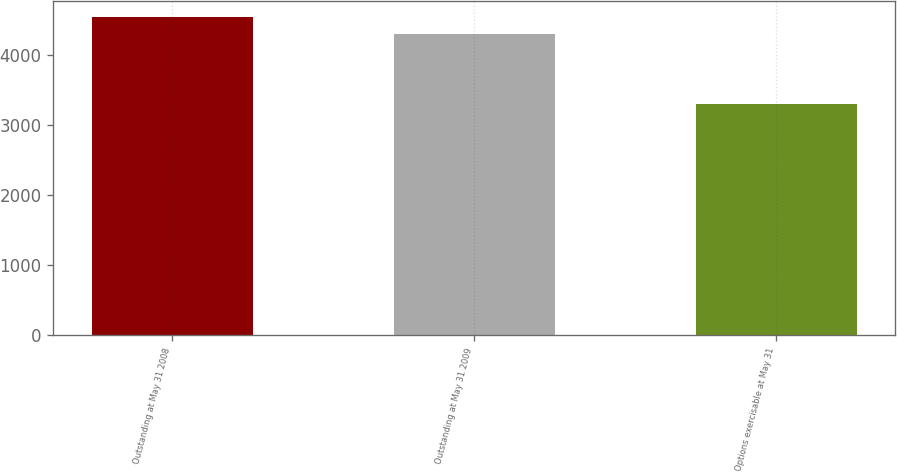Convert chart. <chart><loc_0><loc_0><loc_500><loc_500><bar_chart><fcel>Outstanding at May 31 2008<fcel>Outstanding at May 31 2009<fcel>Options exercisable at May 31<nl><fcel>4536<fcel>4293<fcel>3292<nl></chart> 